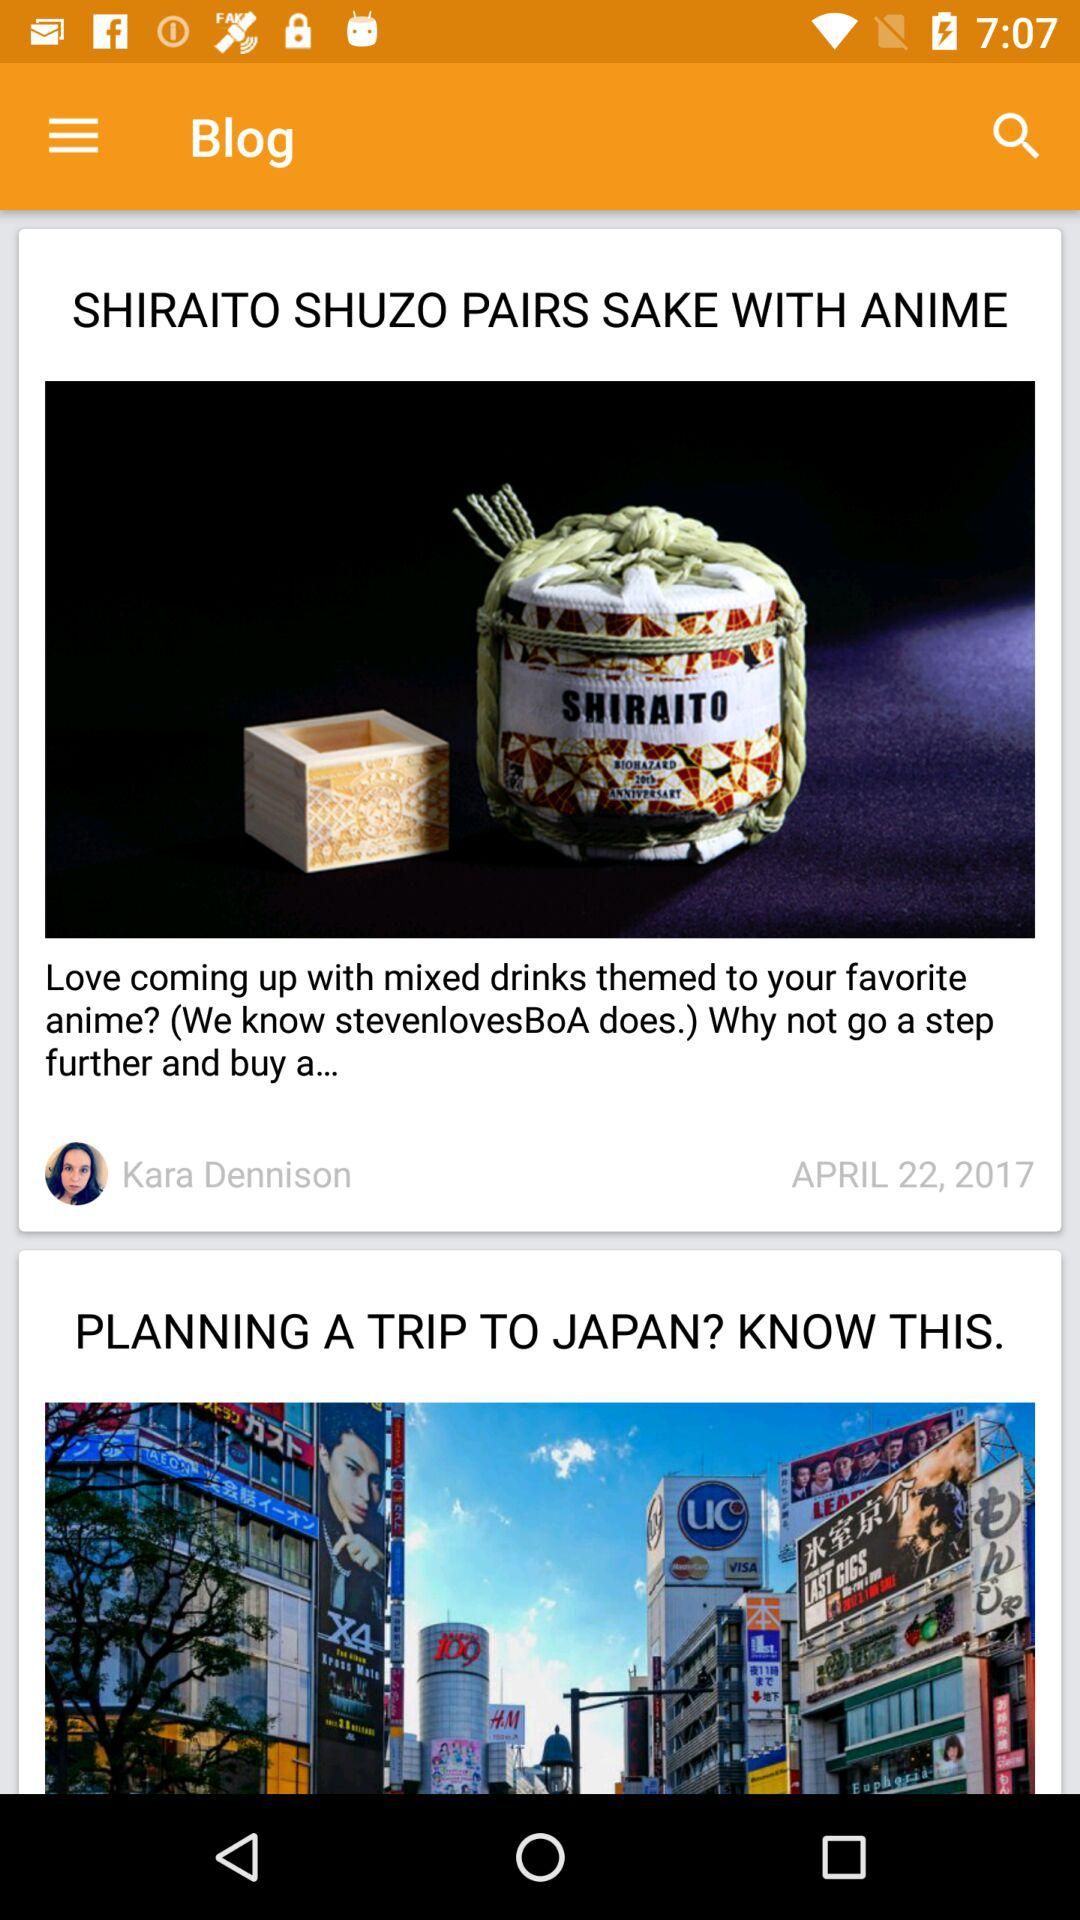What is the publication date of the blog "SHIRAITO SHUZO PAIRS SAKE WITH ANIME"? The publication date of the blog "SHIRAITO SHUZO PAIRS SAKE WITH ANIME" is April 22, 2017. 